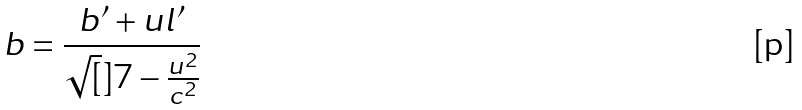<formula> <loc_0><loc_0><loc_500><loc_500>b = \frac { b ^ { \prime } + u l ^ { \prime } } { \sqrt { [ } ] { 7 - \frac { u ^ { 2 } } { c ^ { 2 } } } }</formula> 